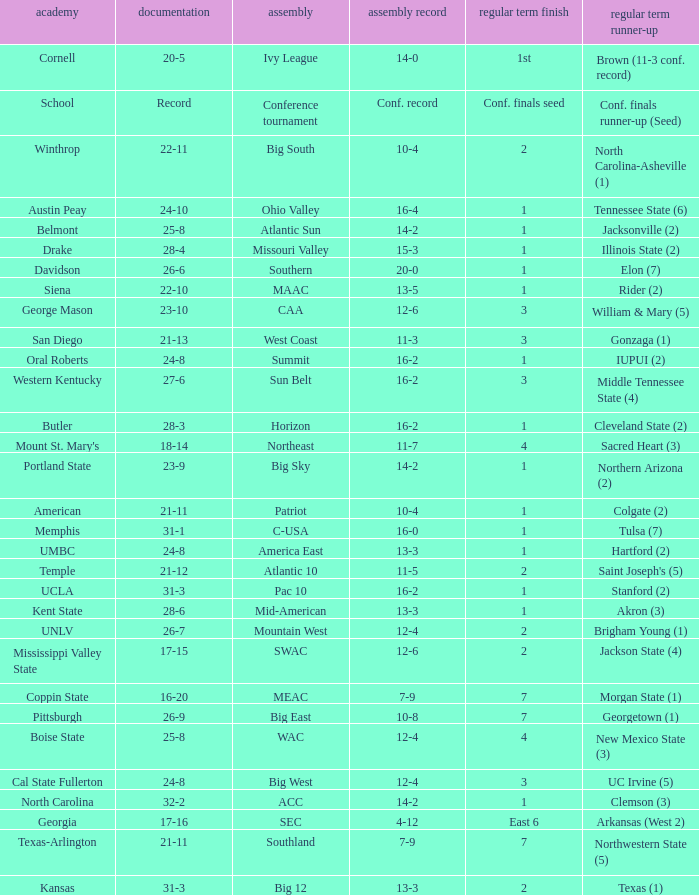What was the overall record of UMBC? 24-8. 